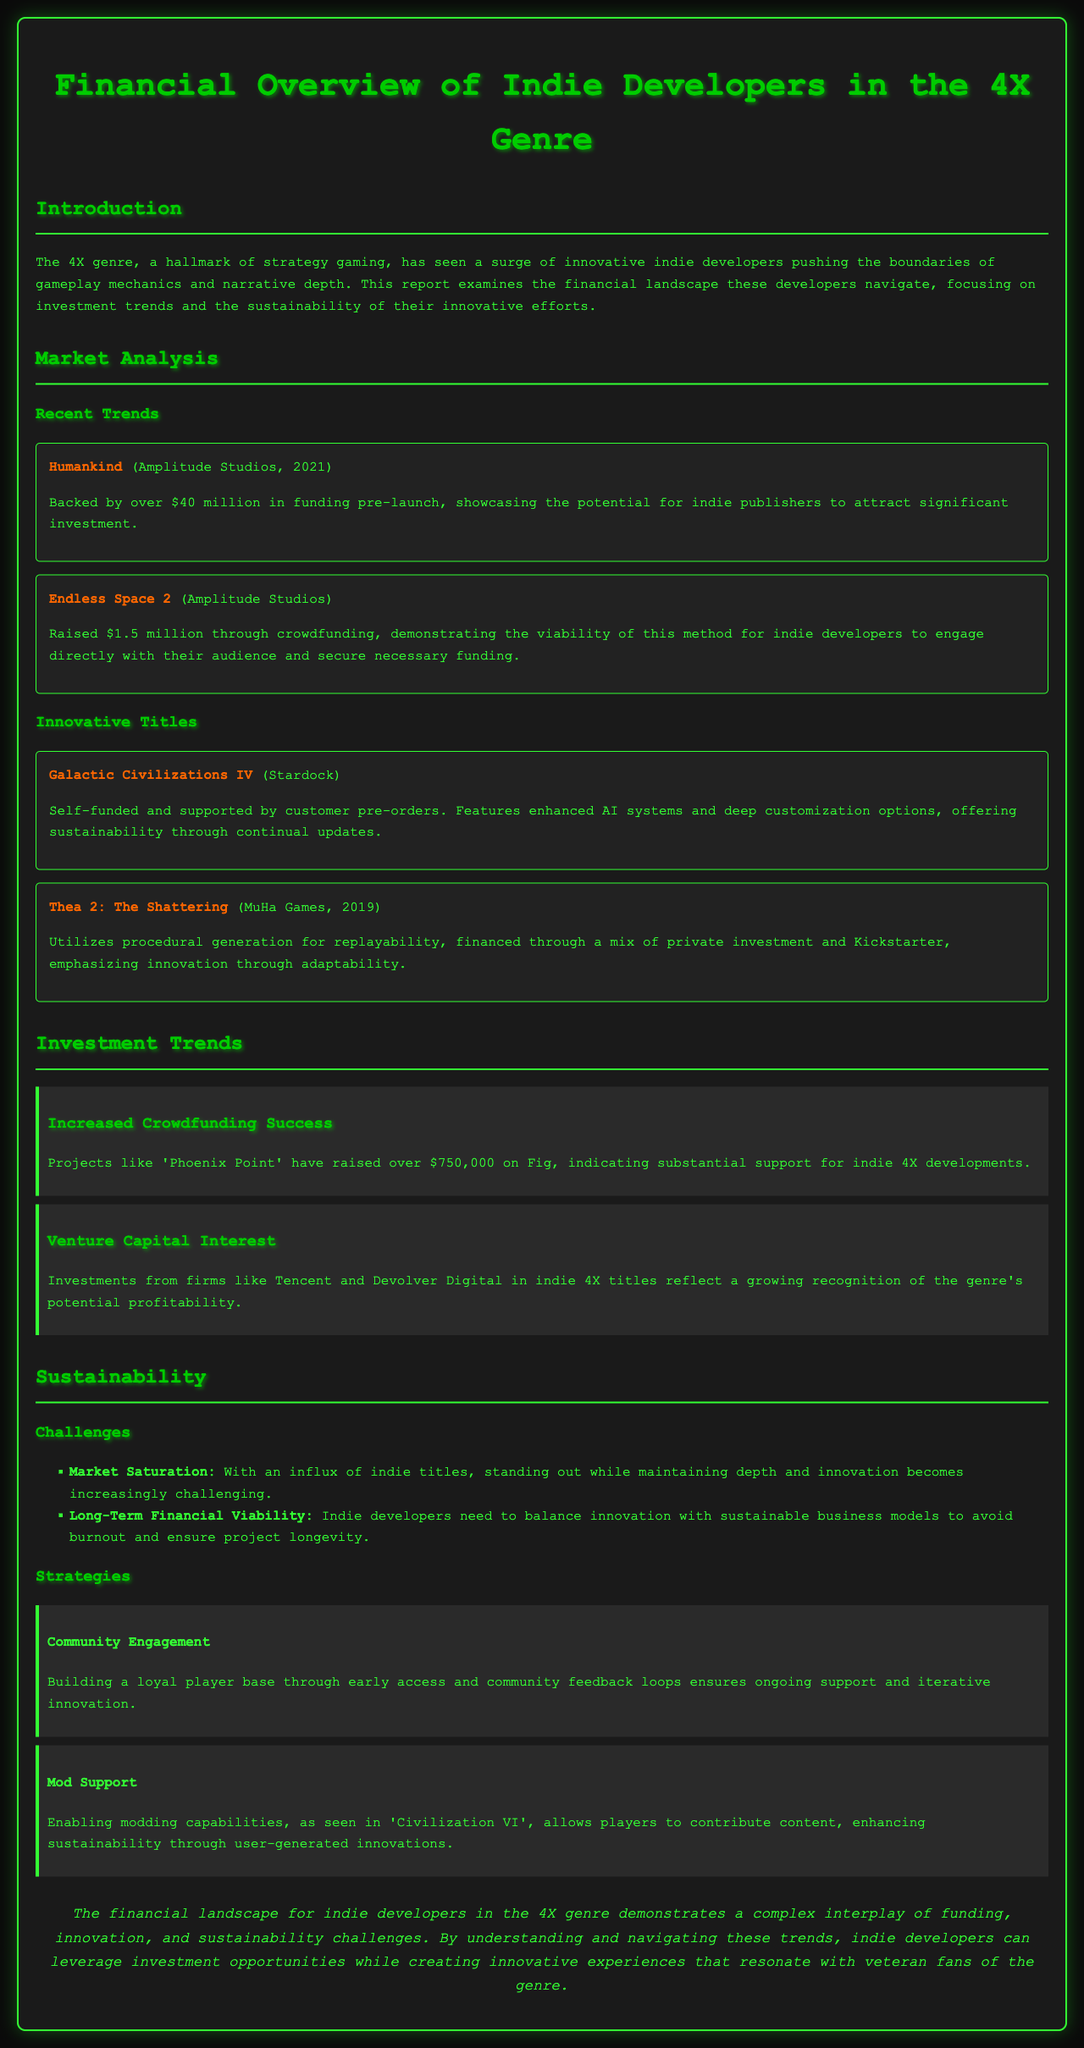what is the funding amount for Humankind? The document states that Humankind was backed by over $40 million in funding.
Answer: over $40 million how much did Endless Space 2 raise through crowdfunding? Endless Space 2 raised $1.5 million through crowdfunding according to the document.
Answer: $1.5 million who developed Galactic Civilizations IV? The document identifies Stardock as the developer of Galactic Civilizations IV.
Answer: Stardock what significant investments reflect venture capital interest in indie 4X titles? The report mentions Tencent and Devolver Digital as firms investing in indie 4X titles.
Answer: Tencent and Devolver Digital which strategy involves community feedback loops? The document states that community engagement involves building a player base through early access and feedback loops.
Answer: Community Engagement what is the primary challenge associated with market saturation? Market saturation poses a challenge for indie developers in standing out while maintaining innovation and depth.
Answer: standing out while maintaining depth and innovation which title utilizes procedural generation for replayability? The document states that Thea 2: The Shattering utilizes procedural generation for replayability.
Answer: Thea 2: The Shattering what is a recommended strategy for sustainability mentioned in the document? Enabling modding capabilities is mentioned as a recommended strategy for sustainability.
Answer: Mod Support 